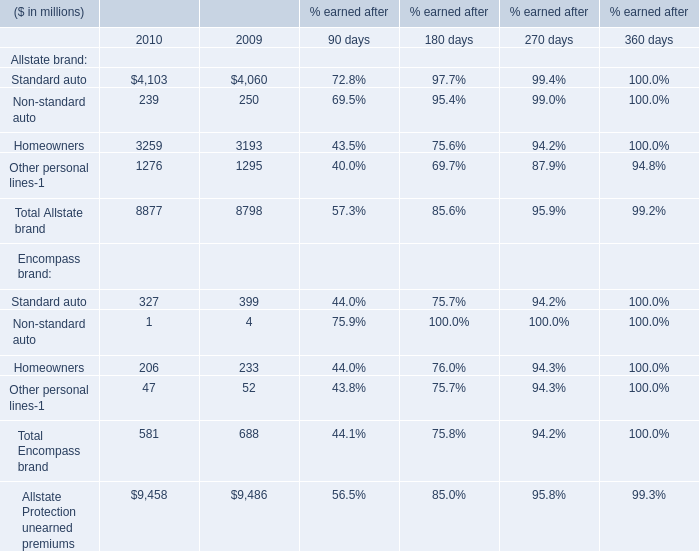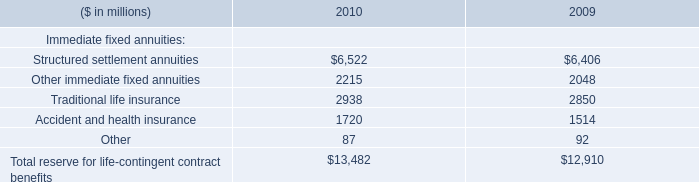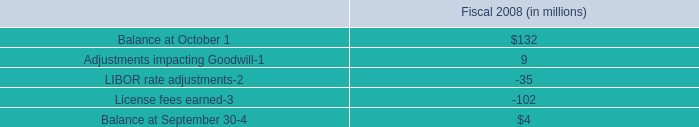How many Allstate brand exceed the average of Allstate brand in 2010? 
Answer: 2. 